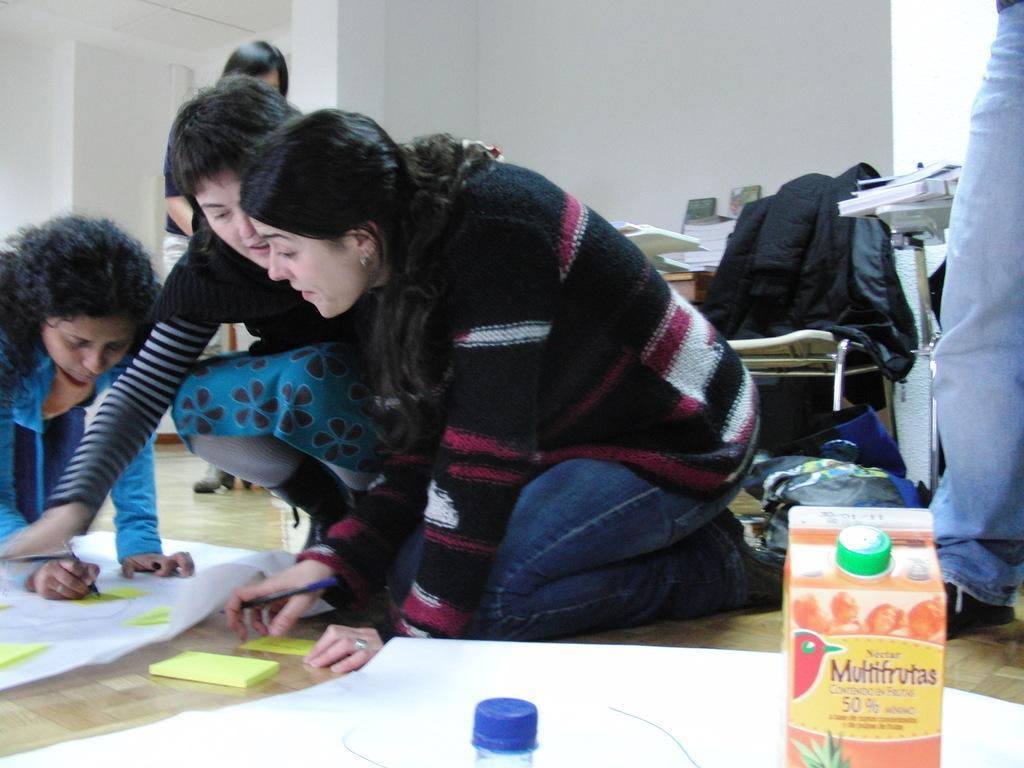Can you describe this image briefly? This picture is clicked inside the room. In the foreground we can see a box and we can see the text, numbers and the depictions of some objects on the box and we can see a bottle and some objects are placed on the ground. On the left we can see the group of people seems to be squatting on the ground. In the left corner there is a person holding a pen, seems to be sitting on the ground and seems to be writing on the paper. In the background we can see the wall and we can see the tables containing books and many other objects and we can see an object is placed on the chair. In the right corner there is a person standing on the ground. On the left there is a person seems to be standing on the ground and we can see many other objects in the background. 